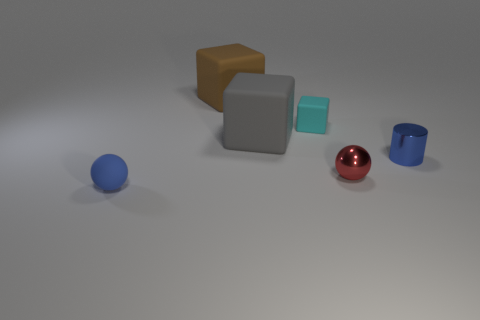Can you describe the lighting in the scene? Where might the light source be located? The lighting in the scene is diffused, casting soft shadows under and around the objects, suggesting an overhead light source. The shadows are slightly elongated, indicating that the light might be positioned slightly to the front and above the objects. There are no harsh direct lights or strong reflections, aside from the gleam on the red sphere, which indicates a softer ambient light present in the scene. 